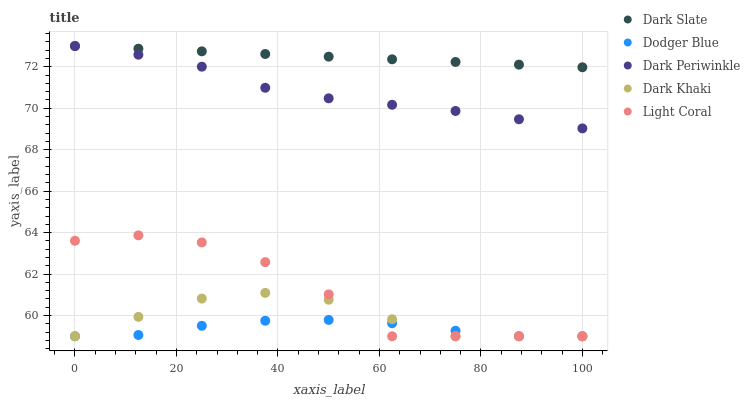Does Dodger Blue have the minimum area under the curve?
Answer yes or no. Yes. Does Dark Slate have the maximum area under the curve?
Answer yes or no. Yes. Does Dark Slate have the minimum area under the curve?
Answer yes or no. No. Does Dodger Blue have the maximum area under the curve?
Answer yes or no. No. Is Dark Slate the smoothest?
Answer yes or no. Yes. Is Light Coral the roughest?
Answer yes or no. Yes. Is Dodger Blue the smoothest?
Answer yes or no. No. Is Dodger Blue the roughest?
Answer yes or no. No. Does Dark Khaki have the lowest value?
Answer yes or no. Yes. Does Dark Slate have the lowest value?
Answer yes or no. No. Does Dark Periwinkle have the highest value?
Answer yes or no. Yes. Does Dodger Blue have the highest value?
Answer yes or no. No. Is Dark Khaki less than Dark Periwinkle?
Answer yes or no. Yes. Is Dark Slate greater than Light Coral?
Answer yes or no. Yes. Does Light Coral intersect Dodger Blue?
Answer yes or no. Yes. Is Light Coral less than Dodger Blue?
Answer yes or no. No. Is Light Coral greater than Dodger Blue?
Answer yes or no. No. Does Dark Khaki intersect Dark Periwinkle?
Answer yes or no. No. 